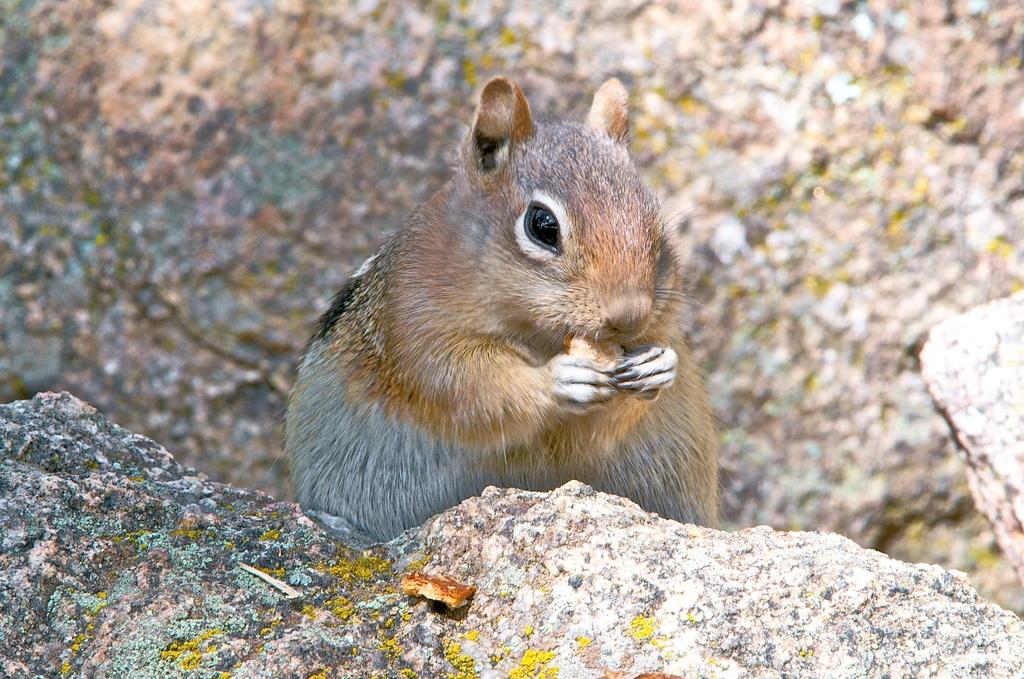What animal is in the center of the image? There is a squirrel in the center of the image. What object can be seen at the bottom of the image? There is a rock at the bottom of the image. What company is the squirrel working for in the image? There is no indication in the image that the squirrel is working for a company. Is the squirrel driving a vehicle in the image? There is no vehicle present in the image, and the squirrel is not depicted as driving. 